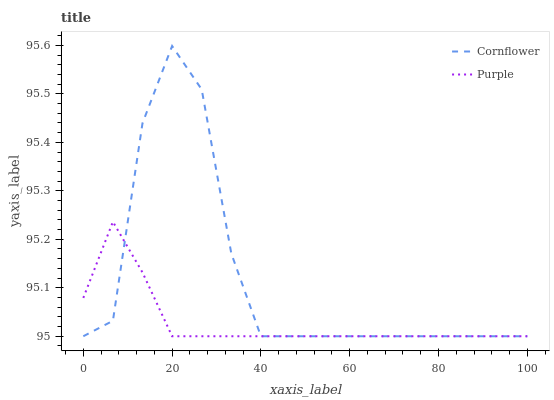Does Purple have the minimum area under the curve?
Answer yes or no. Yes. Does Cornflower have the maximum area under the curve?
Answer yes or no. Yes. Does Cornflower have the minimum area under the curve?
Answer yes or no. No. Is Purple the smoothest?
Answer yes or no. Yes. Is Cornflower the roughest?
Answer yes or no. Yes. Is Cornflower the smoothest?
Answer yes or no. No. Does Purple have the lowest value?
Answer yes or no. Yes. Does Cornflower have the highest value?
Answer yes or no. Yes. Does Cornflower intersect Purple?
Answer yes or no. Yes. Is Cornflower less than Purple?
Answer yes or no. No. Is Cornflower greater than Purple?
Answer yes or no. No. 